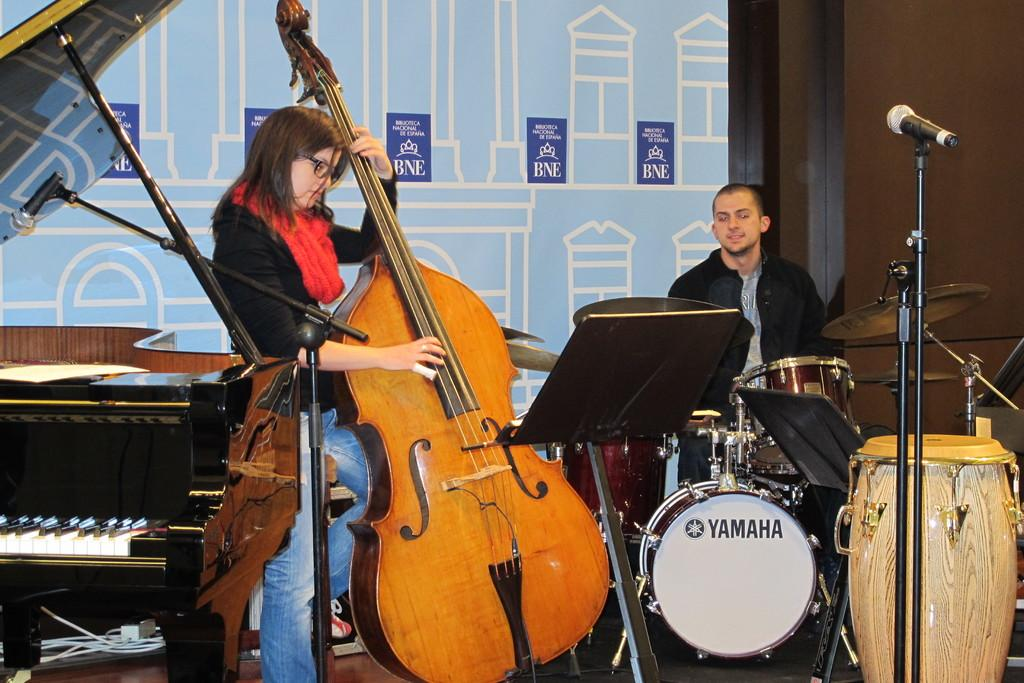What is the woman in the image doing? The woman is standing and playing a guitar in the image. Can you describe the other person in the image? The other person is sitting and playing drums. What musical instrument is also present in the image? There is a piano in the image. What type of kettle is being used to improve the acoustics in the image? There is no kettle present in the image, and the acoustics are not mentioned or affected by any visible objects. 